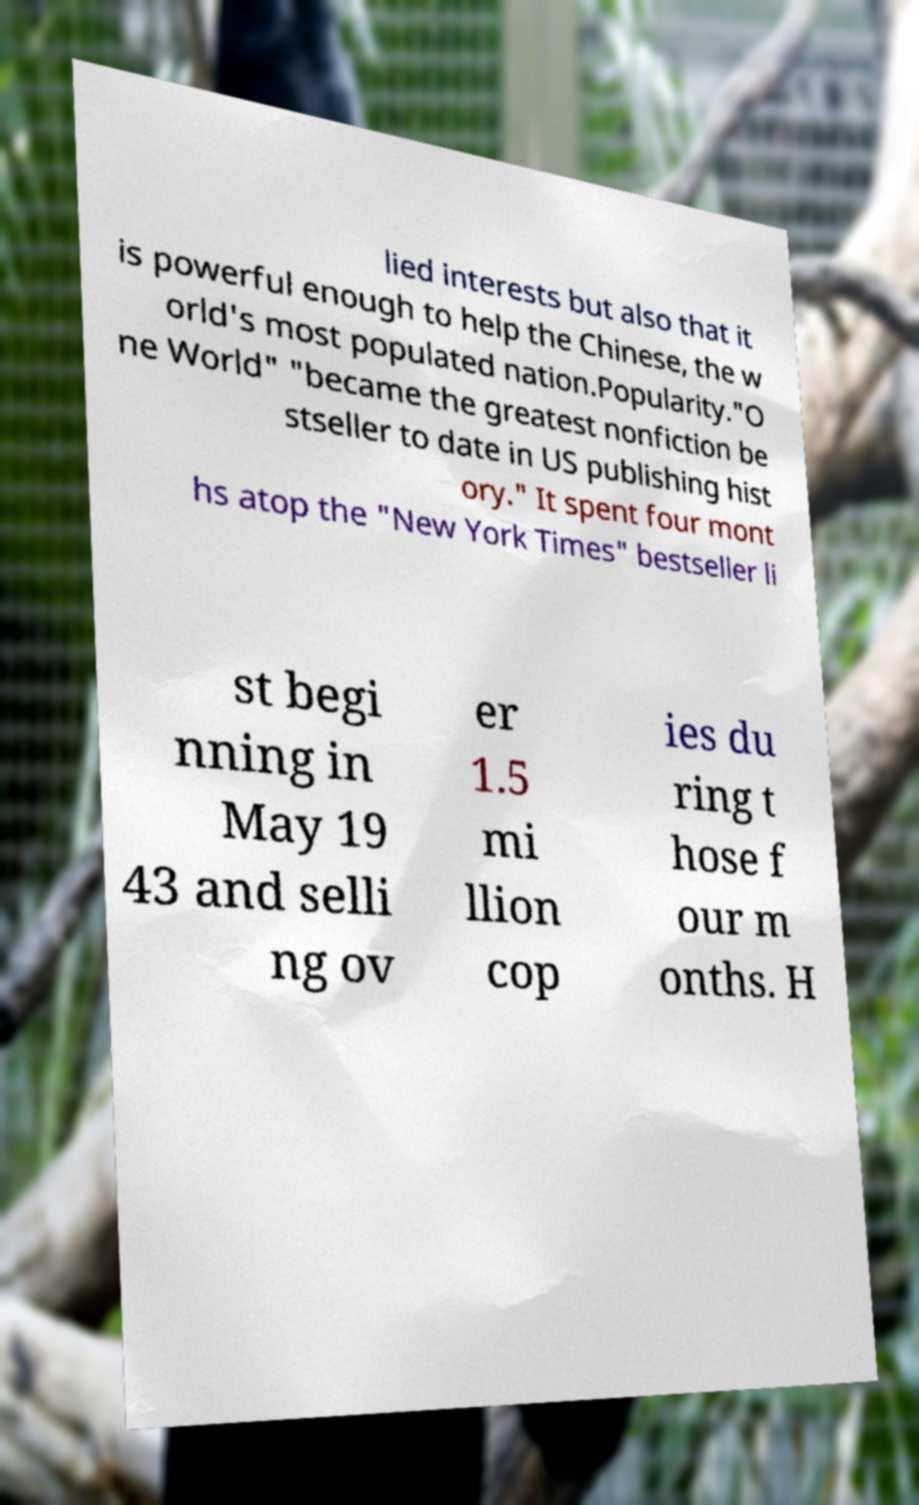For documentation purposes, I need the text within this image transcribed. Could you provide that? lied interests but also that it is powerful enough to help the Chinese, the w orld's most populated nation.Popularity."O ne World" "became the greatest nonfiction be stseller to date in US publishing hist ory." It spent four mont hs atop the "New York Times" bestseller li st begi nning in May 19 43 and selli ng ov er 1.5 mi llion cop ies du ring t hose f our m onths. H 